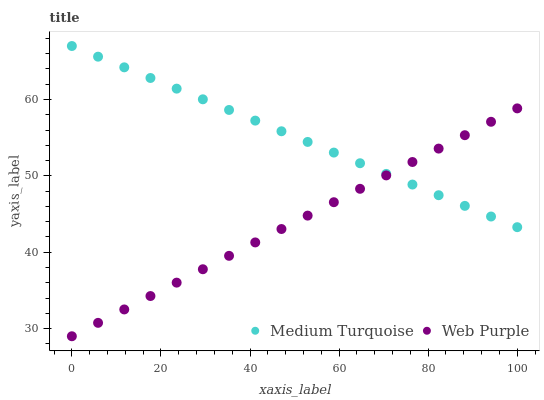Does Web Purple have the minimum area under the curve?
Answer yes or no. Yes. Does Medium Turquoise have the maximum area under the curve?
Answer yes or no. Yes. Does Medium Turquoise have the minimum area under the curve?
Answer yes or no. No. Is Medium Turquoise the smoothest?
Answer yes or no. Yes. Is Web Purple the roughest?
Answer yes or no. Yes. Is Medium Turquoise the roughest?
Answer yes or no. No. Does Web Purple have the lowest value?
Answer yes or no. Yes. Does Medium Turquoise have the lowest value?
Answer yes or no. No. Does Medium Turquoise have the highest value?
Answer yes or no. Yes. Does Medium Turquoise intersect Web Purple?
Answer yes or no. Yes. Is Medium Turquoise less than Web Purple?
Answer yes or no. No. Is Medium Turquoise greater than Web Purple?
Answer yes or no. No. 